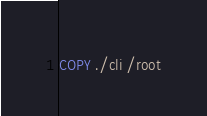<code> <loc_0><loc_0><loc_500><loc_500><_Dockerfile_>COPY ./cli /root</code> 